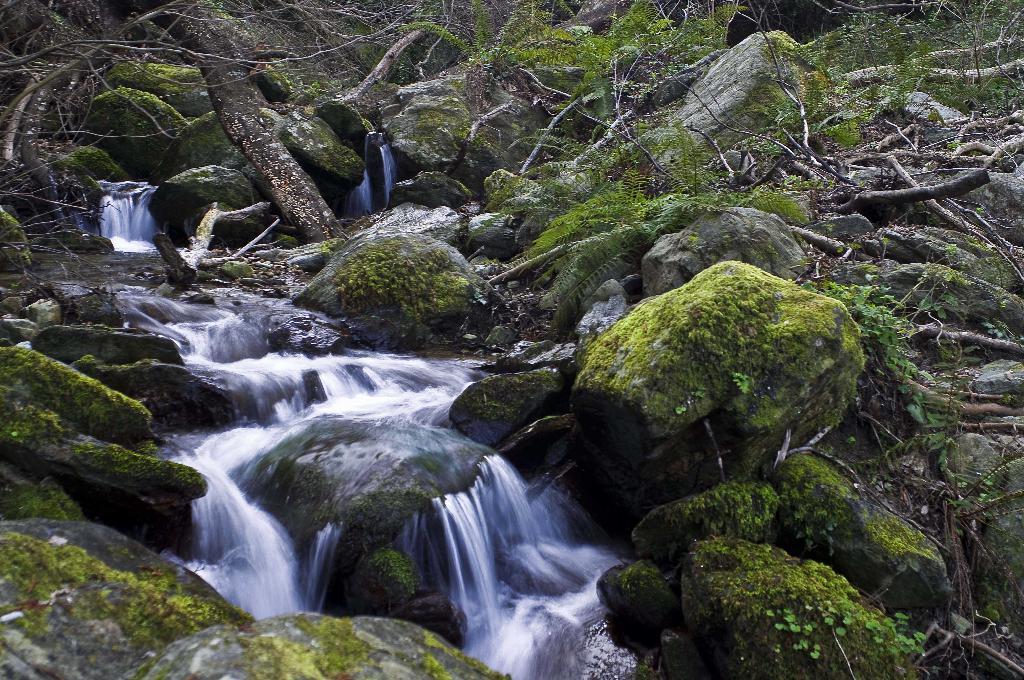Could you give a brief overview of what you see in this image? This image is taken outdoors. In this image there is a waterfall with water. There are many rocks and stones covered with algae. There are a few trees and plants with leaves, stems and branches. 